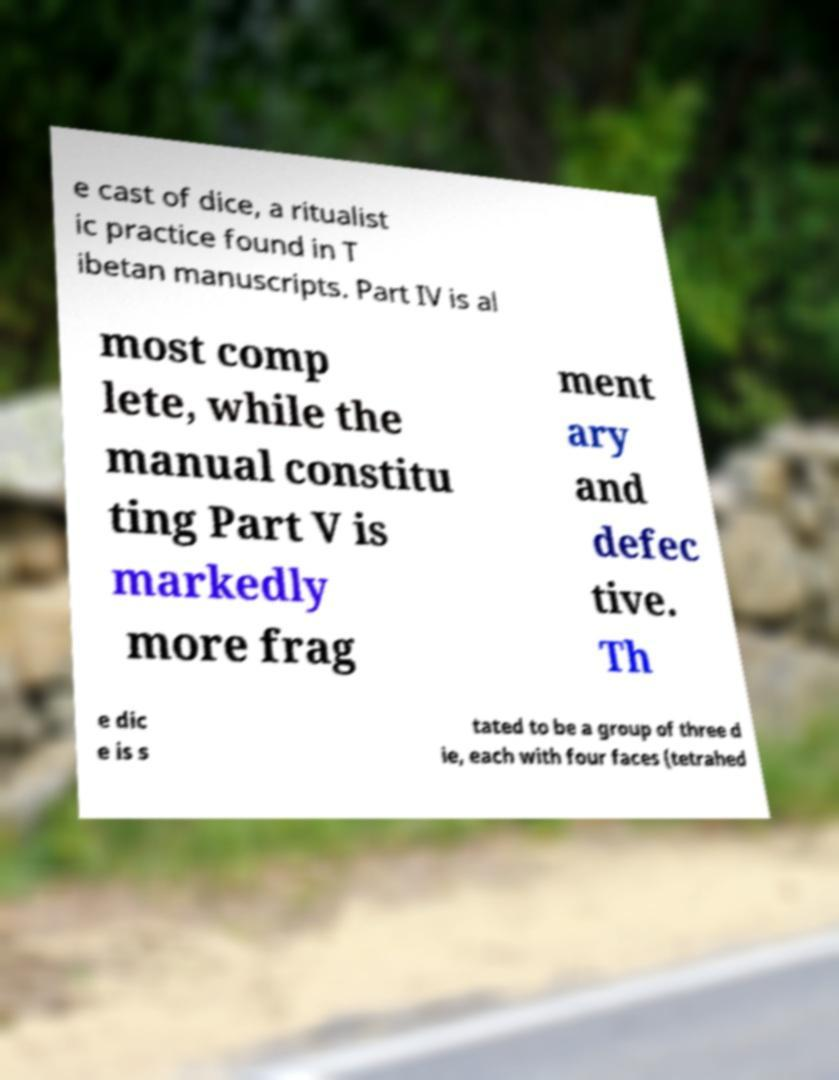What messages or text are displayed in this image? I need them in a readable, typed format. e cast of dice, a ritualist ic practice found in T ibetan manuscripts. Part IV is al most comp lete, while the manual constitu ting Part V is markedly more frag ment ary and defec tive. Th e dic e is s tated to be a group of three d ie, each with four faces (tetrahed 